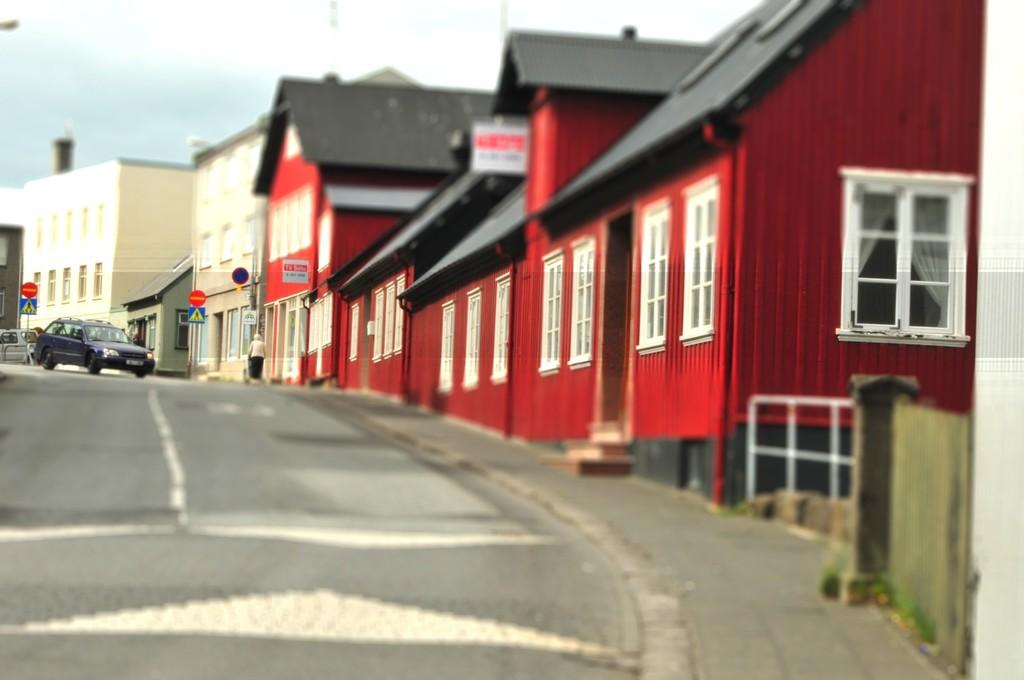What type of vehicle is on the road in the image? There is a black car on the road in the image. What other objects can be seen in the image besides the car? There are sign boards, buildings, and a white fence visible in the image. Where are the buildings located in the image? The buildings are on the right side of the image. What is visible at the top of the image? The sky is visible at the top of the image. How many beds can be seen in the image? There are no beds present in the image. Is there a volleyball game happening in the image? There is no volleyball game or any reference to volleyball in the image. 